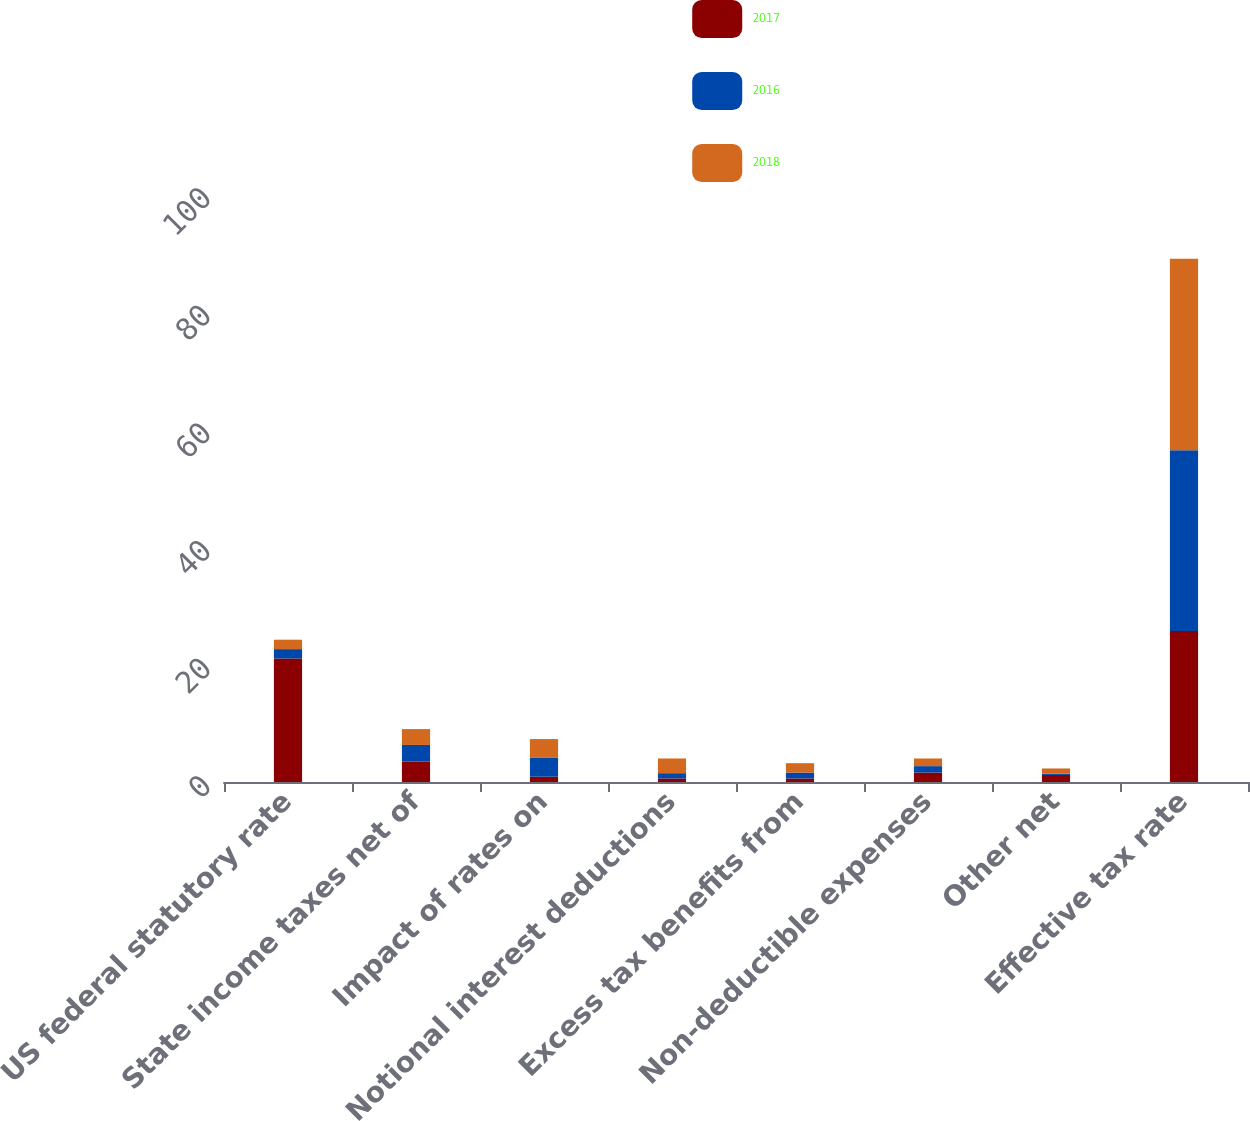Convert chart to OTSL. <chart><loc_0><loc_0><loc_500><loc_500><stacked_bar_chart><ecel><fcel>US federal statutory rate<fcel>State income taxes net of<fcel>Impact of rates on<fcel>Notional interest deductions<fcel>Excess tax benefits from<fcel>Non-deductible expenses<fcel>Other net<fcel>Effective tax rate<nl><fcel>2017<fcel>21<fcel>3.5<fcel>0.9<fcel>0.6<fcel>0.6<fcel>1.6<fcel>1.2<fcel>25.7<nl><fcel>2016<fcel>1.6<fcel>2.8<fcel>3.2<fcel>0.9<fcel>1<fcel>1.1<fcel>0.2<fcel>30.7<nl><fcel>2018<fcel>1.6<fcel>2.7<fcel>3.2<fcel>2.5<fcel>1.6<fcel>1.3<fcel>0.9<fcel>32.6<nl></chart> 